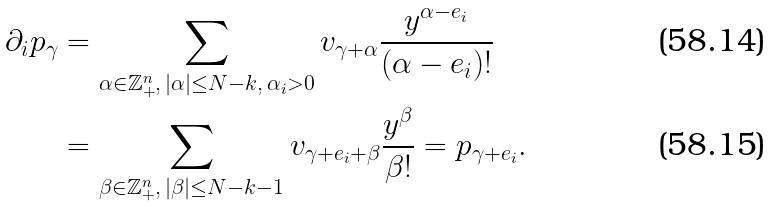<formula> <loc_0><loc_0><loc_500><loc_500>\partial _ { i } p _ { \gamma } & = \sum _ { \alpha \in \mathbb { Z } _ { + } ^ { n } , \, | \alpha | \leq N - k , \, \alpha _ { i } > 0 } v _ { \gamma + \alpha } \frac { y ^ { \alpha - e _ { i } } } { ( \alpha - e _ { i } ) ! } \\ & = \sum _ { \beta \in \mathbb { Z } _ { + } ^ { n } , \, | \beta | \leq N - k - 1 } v _ { \gamma + e _ { i } + \beta } \frac { y ^ { \beta } } { \beta ! } = p _ { \gamma + e _ { i } } .</formula> 